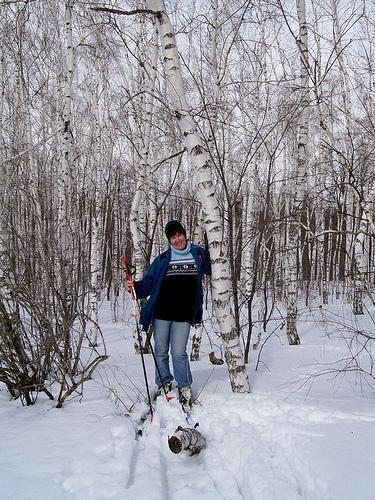How many women are in the photo?
Give a very brief answer. 1. 